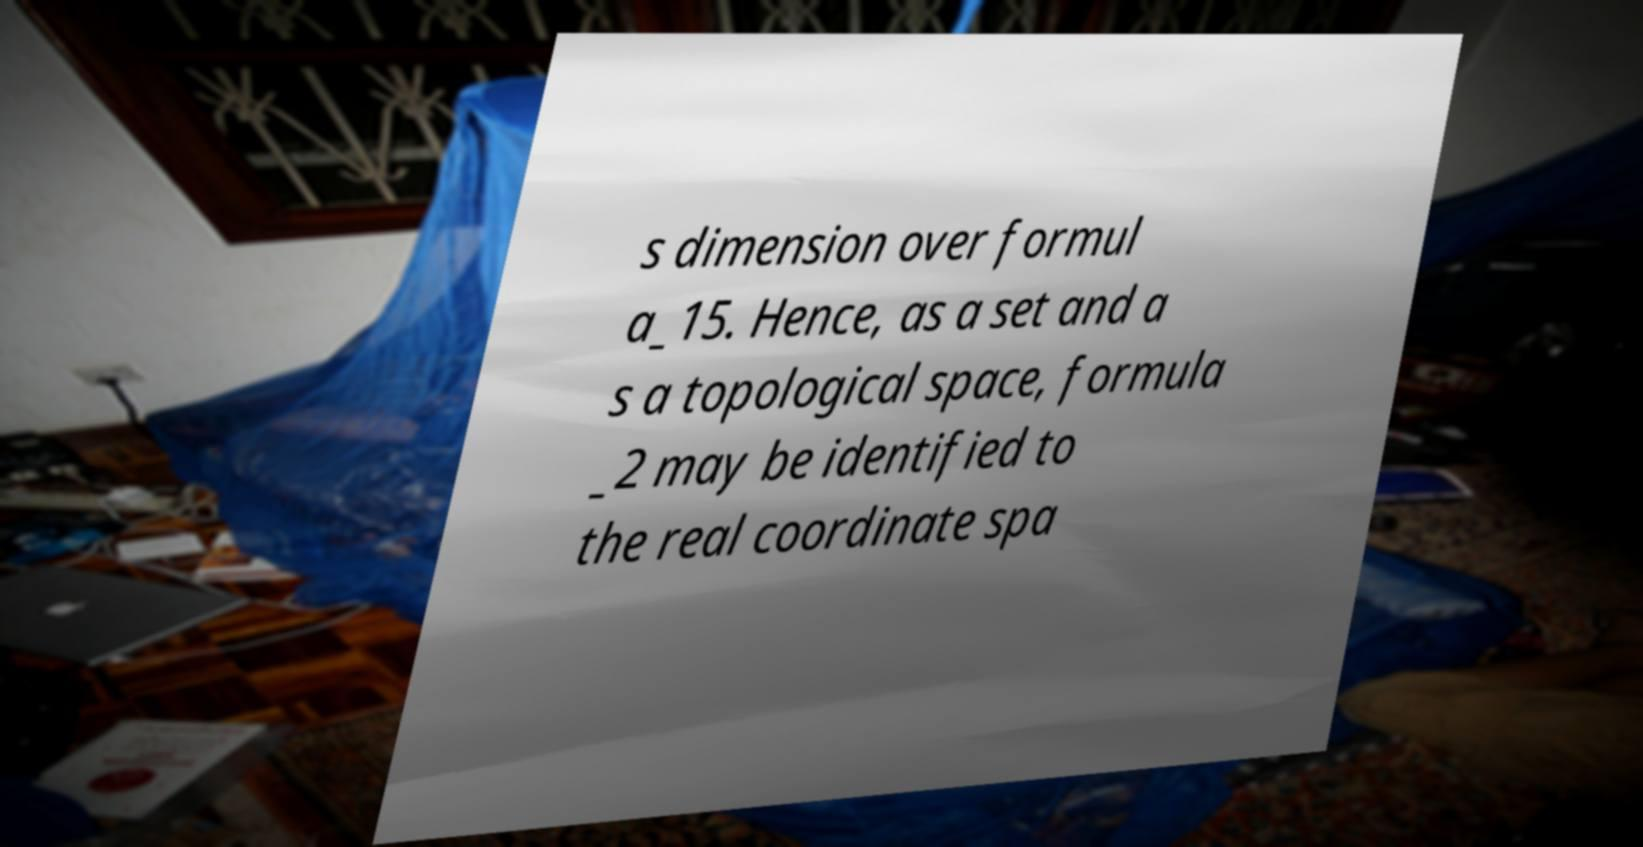What messages or text are displayed in this image? I need them in a readable, typed format. s dimension over formul a_15. Hence, as a set and a s a topological space, formula _2 may be identified to the real coordinate spa 